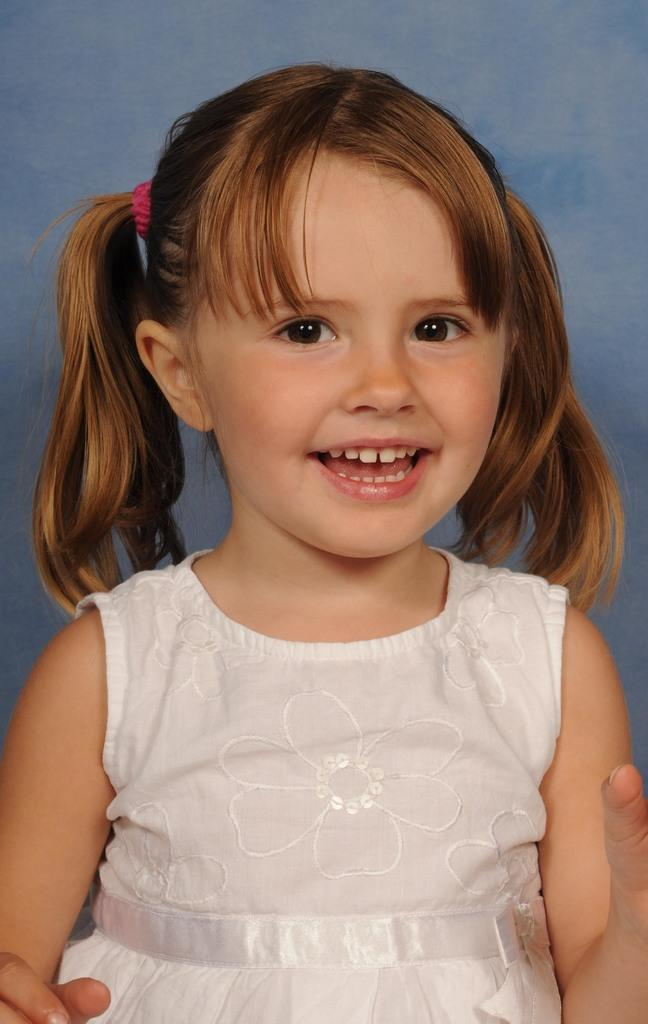Who is the main subject in the image? There is a girl in the image. What is the girl wearing? The girl is wearing a frock. What expression does the girl have on her face? The girl is smiling. Where is the drain located in the image? There is no drain present in the image. Is the girl playing basketball in the image? There is no basketball or indication of basketball playing in the image. 